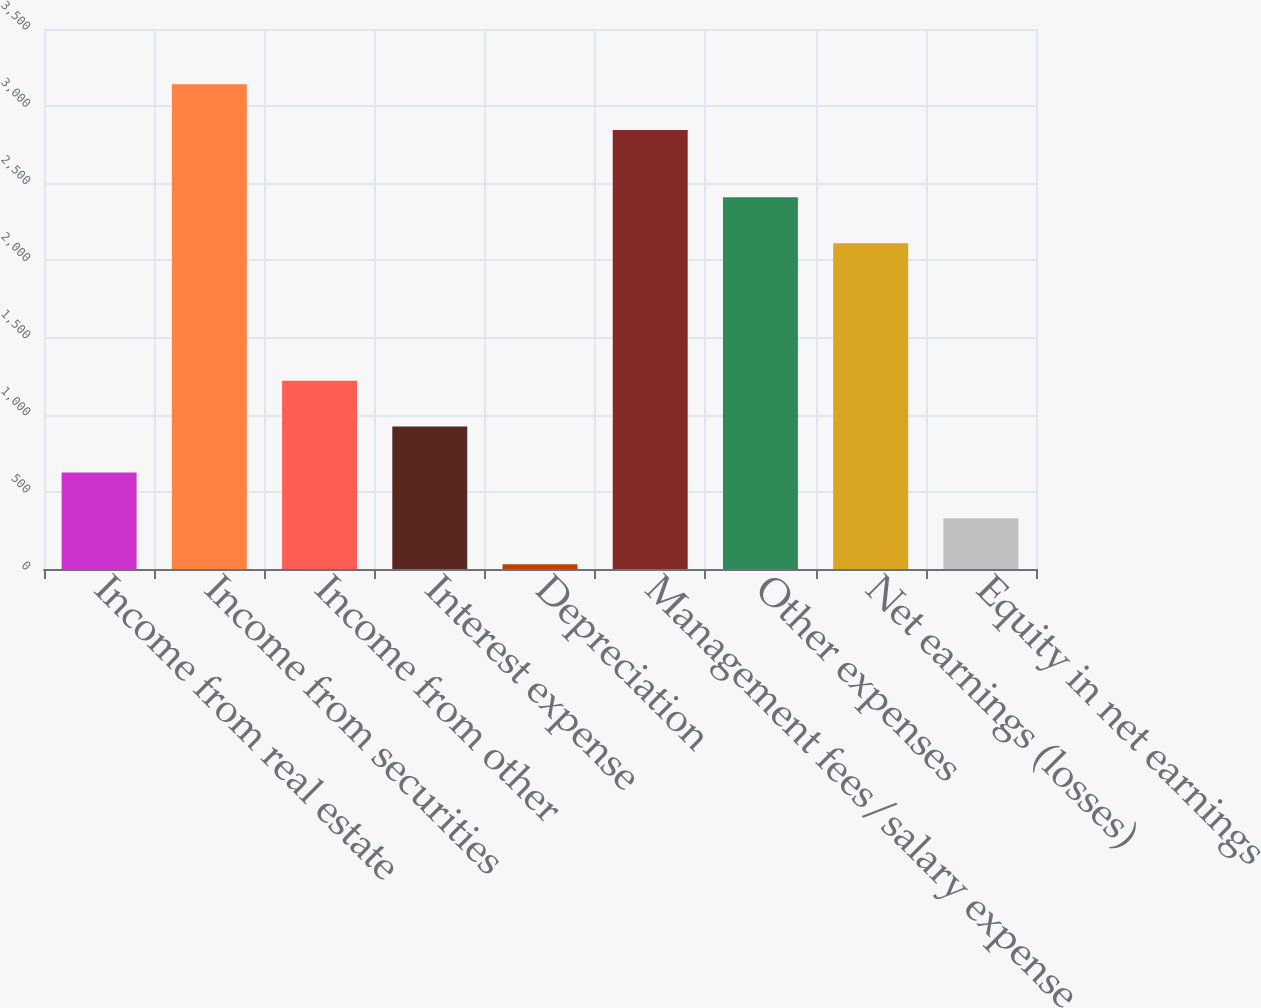Convert chart to OTSL. <chart><loc_0><loc_0><loc_500><loc_500><bar_chart><fcel>Income from real estate<fcel>Income from securities<fcel>Income from other<fcel>Interest expense<fcel>Depreciation<fcel>Management fees/salary expense<fcel>Other expenses<fcel>Net earnings (losses)<fcel>Equity in net earnings<nl><fcel>625.6<fcel>3142.3<fcel>1220.2<fcel>922.9<fcel>31<fcel>2845<fcel>2409.4<fcel>2112.1<fcel>328.3<nl></chart> 